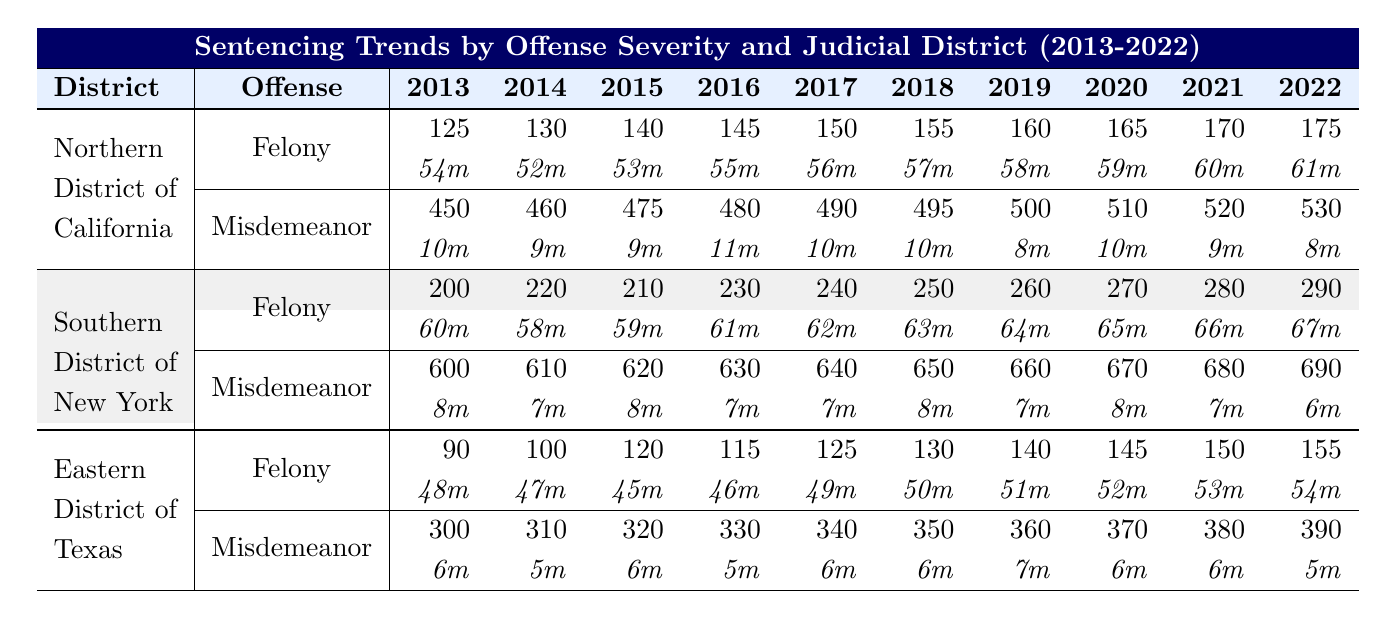What was the total count of felonies recorded in the Southern District of New York in 2017? Referring to the table, the count of felonies in the Southern District of New York for the year 2017 is 240.
Answer: 240 How many misdemeanors were recorded in the Northern District of California in 2022? According to the table, the number of misdemeanors in the Northern District of California for 2022 is 530.
Answer: 530 What is the average sentence in months for felonies in the Eastern District of Texas in 2020? The table shows that the average sentence for felonies in the Eastern District of Texas in 2020 is 52 months.
Answer: 52m Which district had the highest average sentence for felonies in 2022? By examining the average sentences for felonies in 2022, we find that the Southern District of New York had the highest average with 67 months.
Answer: Southern District of New York What was the difference in felony counts between 2013 and 2022 in the Northern District of California? To find the difference, we subtract the count in 2013 (125) from that in 2022 (175): 175 - 125 = 50.
Answer: 50 True or False: The average sentence for misdemeanors in the Southern District of New York decreased from 2013 to 2022. Evaluating the years, the average sentence months for misdemeanors in this district were 8 in 2013 and decreased to 6 in 2022, confirming a decrease.
Answer: True In which year did the Eastern District of Texas have its highest counts of misdemeanors? The table indicates that misdemeanors peaked at 390 in 2022, which is the highest count over the ten years presented.
Answer: 2022 What is the total count of felonies across all districts in 2016? Calculating the total for 2016: Northern District of California (145) + Southern District of New York (230) + Eastern District of Texas (115) = 490.
Answer: 490 How many more felonies were recorded in the Southern District of New York in 2021 than in 2013? The data shows 280 felonies in 2021 and 200 in 2013. Thus, the difference is 280 - 200 = 80.
Answer: 80 